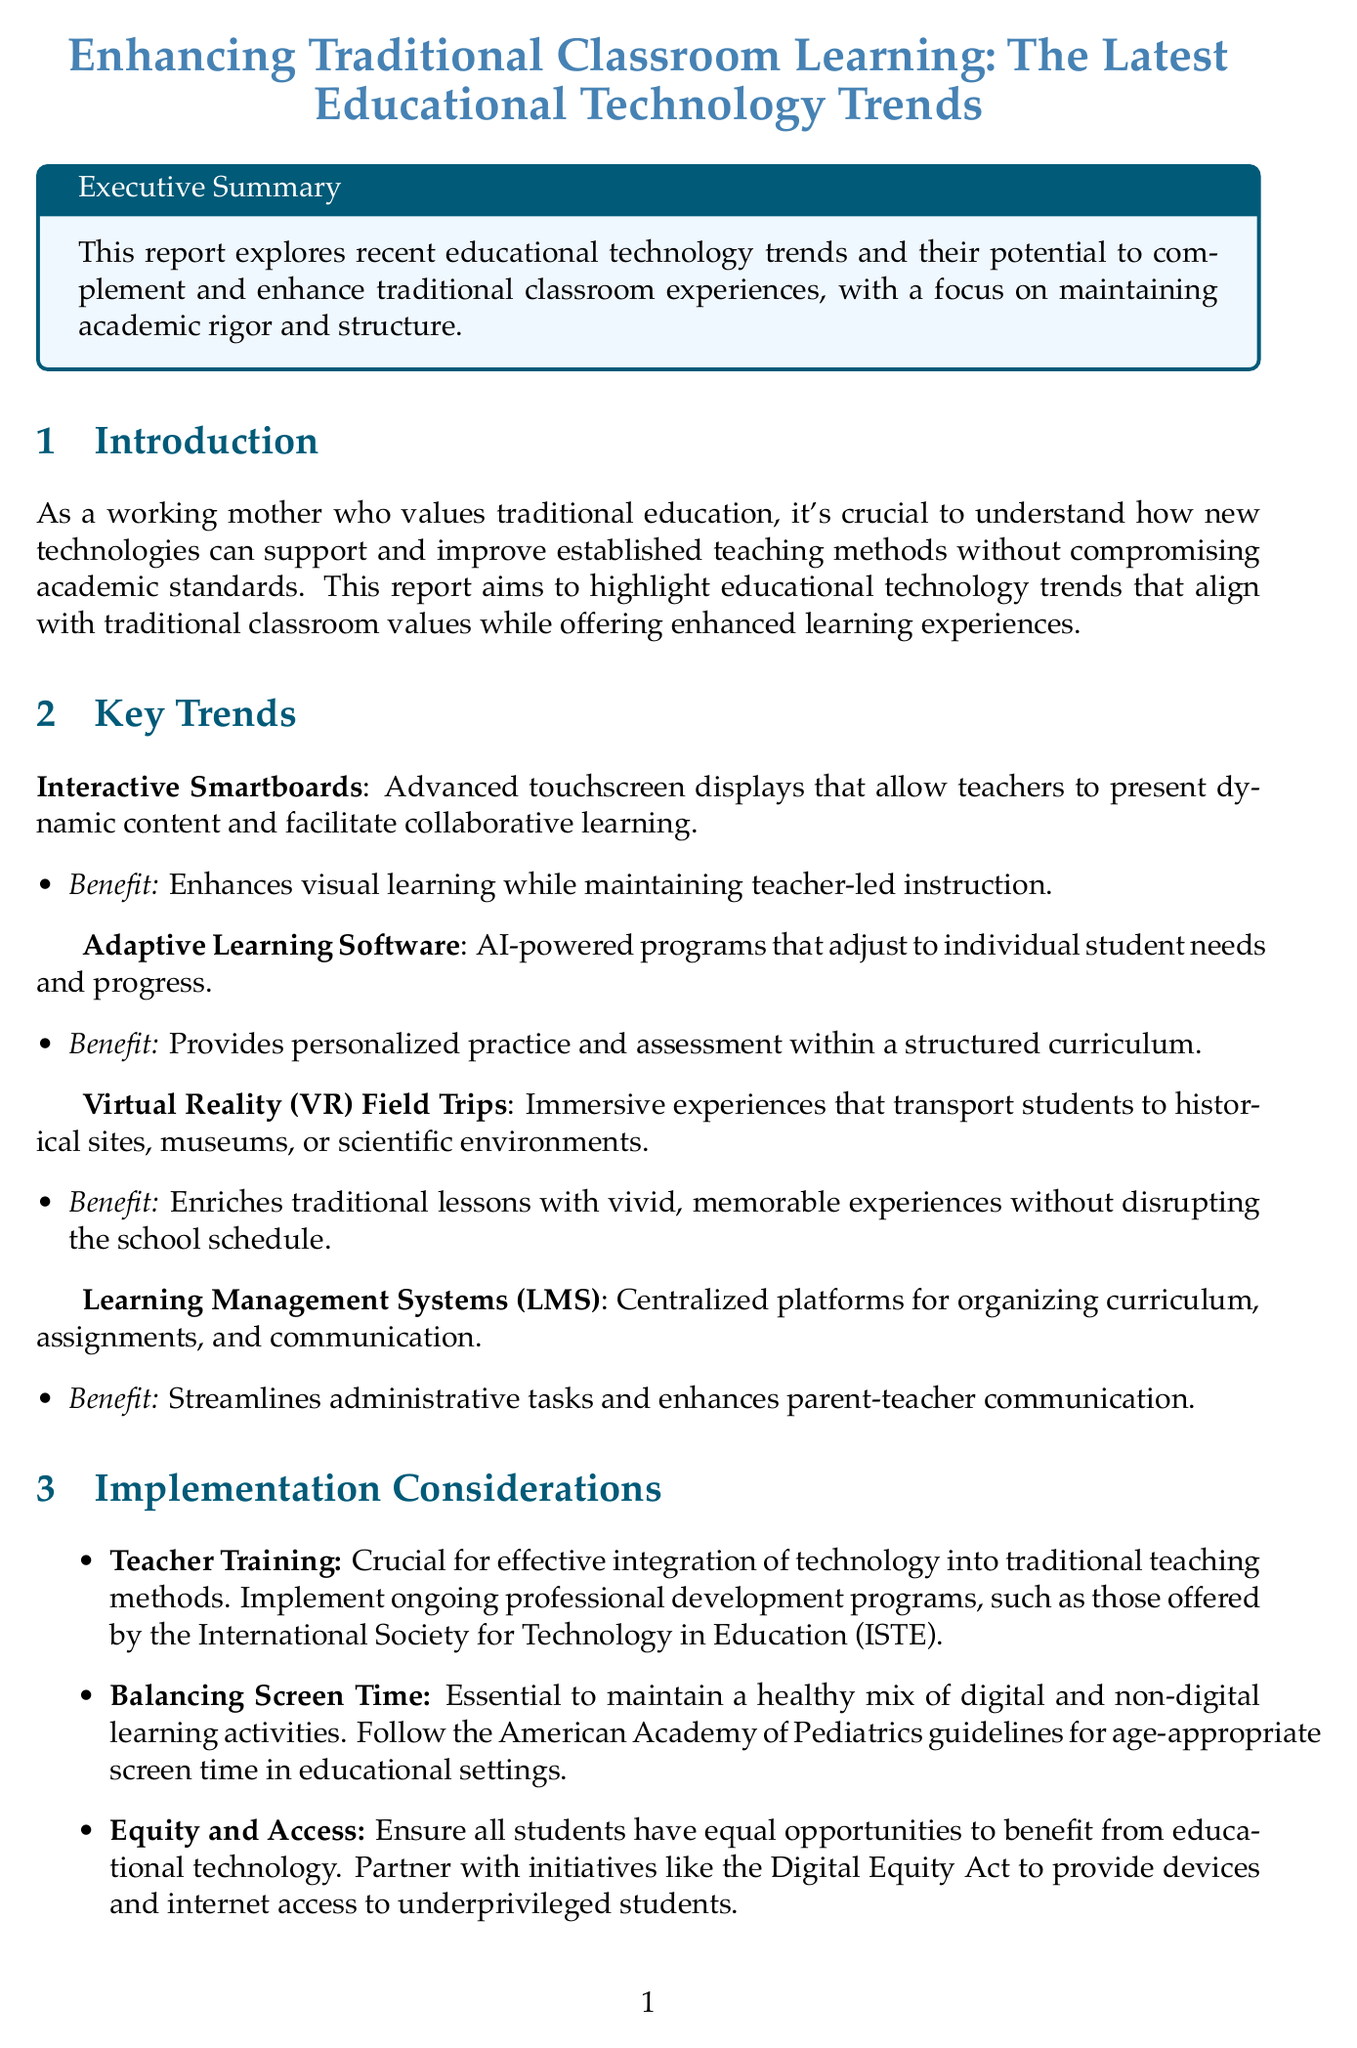What is the title of the report? The title of the report is stated at the beginning and summarizes the content of the document.
Answer: Enhancing Traditional Classroom Learning: The Latest Educational Technology Trends What technology is used for interactive learning? The report specifies a type of technology that allows teachers to present dynamic content and facilitate collaboration in classrooms.
Answer: Interactive Smartboards What recommendation is given for balancing screen time? A guideline is mentioned in the implementation considerations to ensure healthy screen time in educational settings.
Answer: American Academy of Pediatrics guidelines Which school implemented the Harkness Method with digital enhancement? The report provides a case study of a specific school that integrated technology with their discussion method.
Answer: Phillips Exeter Academy, New Hampshire What is the benefit of adaptive learning software? The report outlines the advantages of this technology, focusing on personalized learning.
Answer: Provides personalized practice and assessment within a structured curriculum How many key trends are identified in the report? The report lists different trends under a specific section, allowing for a total count.
Answer: Four What is the significance of teacher training in technology integration? The document emphasizes the importance of this aspect in the effective utilization of technology in classrooms.
Answer: Crucial for effective integration What type of platform is mentioned as an LMS? The report describes a type of system that helps organize curriculum and communication in schools.
Answer: Canvas LMS What is the outcome mentioned for Singapore American School’s technology implementation? The case study specifies results related to hands-on tech labs and their effect on education.
Answer: Enhanced practical application of theoretical concepts without compromising academic rigor 